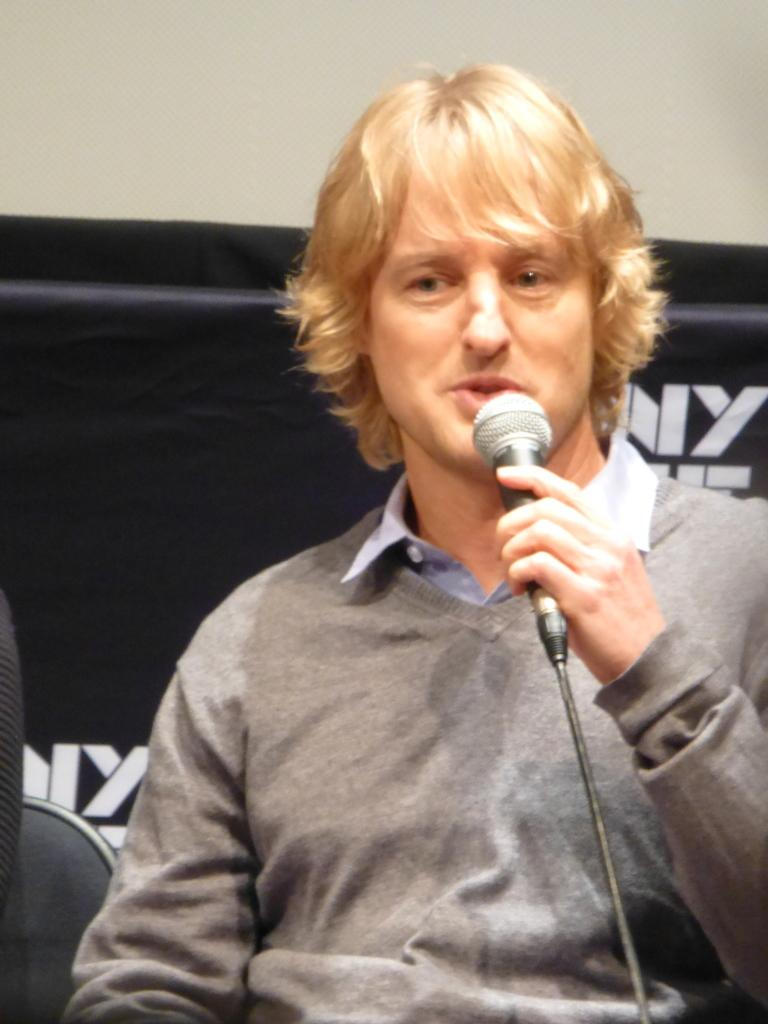Who is in the image? There is a person in the image. What is the person wearing? The person is wearing a grey shirt. What is the person doing in the image? The person is sitting and speaking in front of a microphone. What type of twig can be seen in the person's hand while they are speaking? There is no twig present in the image; the person is holding a microphone. 